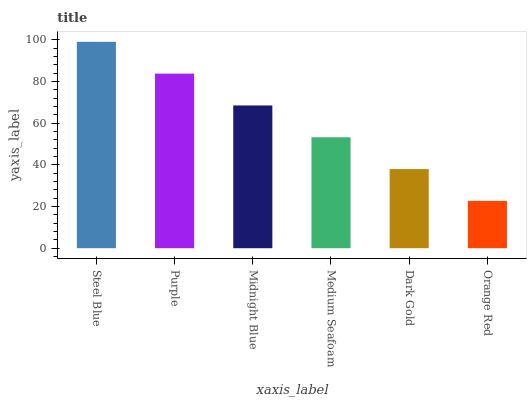Is Orange Red the minimum?
Answer yes or no. Yes. Is Steel Blue the maximum?
Answer yes or no. Yes. Is Purple the minimum?
Answer yes or no. No. Is Purple the maximum?
Answer yes or no. No. Is Steel Blue greater than Purple?
Answer yes or no. Yes. Is Purple less than Steel Blue?
Answer yes or no. Yes. Is Purple greater than Steel Blue?
Answer yes or no. No. Is Steel Blue less than Purple?
Answer yes or no. No. Is Midnight Blue the high median?
Answer yes or no. Yes. Is Medium Seafoam the low median?
Answer yes or no. Yes. Is Steel Blue the high median?
Answer yes or no. No. Is Purple the low median?
Answer yes or no. No. 